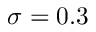Convert formula to latex. <formula><loc_0><loc_0><loc_500><loc_500>\sigma = 0 . 3</formula> 